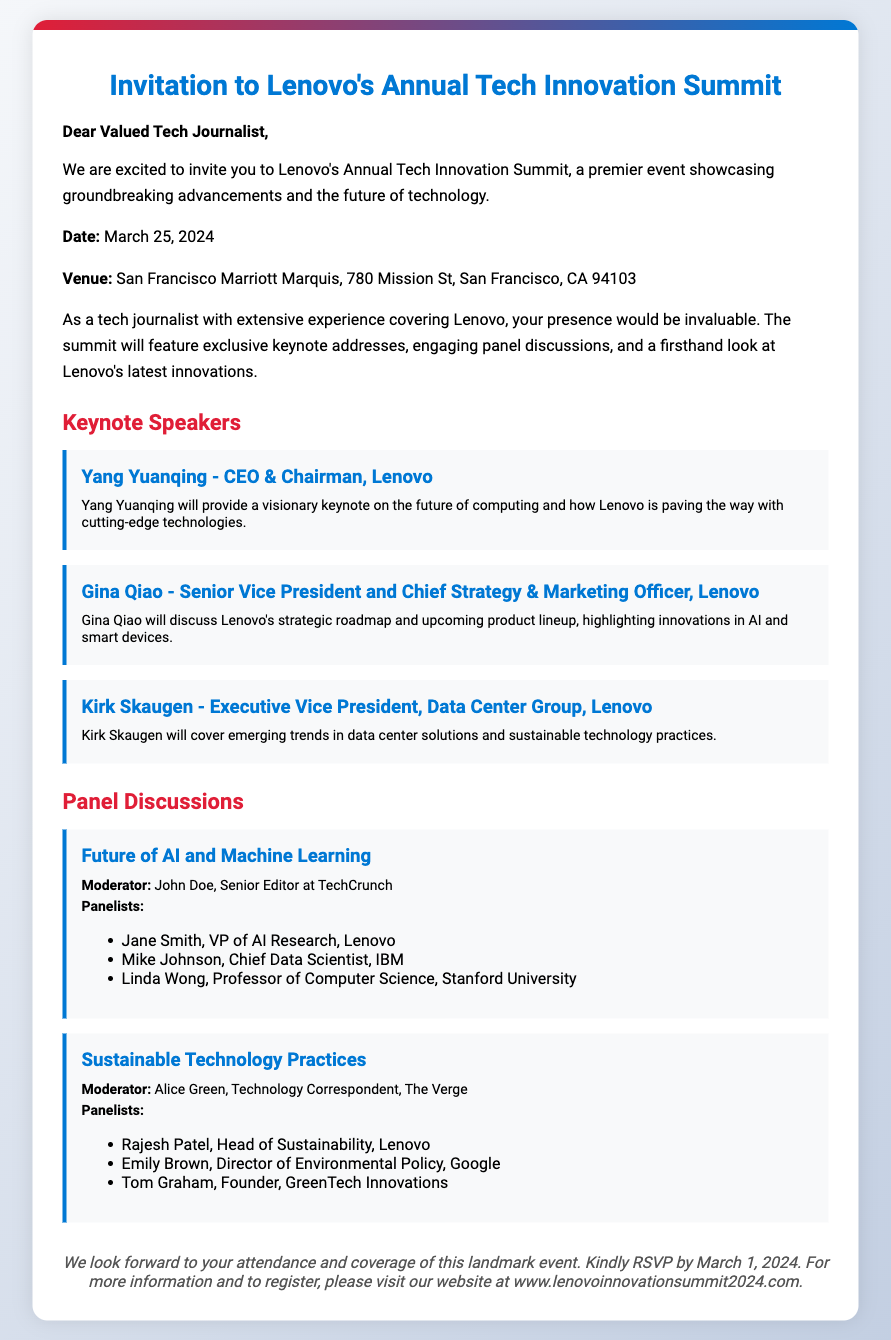What is the date of the event? The date for Lenovo's Annual Tech Innovation Summit is clearly stated in the document.
Answer: March 25, 2024 Where is the event taking place? The document specifies the venue where the summit will be held, providing the complete address.
Answer: San Francisco Marriott Marquis, 780 Mission St, San Francisco, CA 94103 Who is the keynote speaker that is the CEO of Lenovo? The document lists the keynote speakers along with their titles, making it easy to identify the CEO.
Answer: Yang Yuanqing What topic will Kirk Skaugen cover in his keynote? The specific topic of each keynote address is mentioned, allowing for easy extraction of this information.
Answer: Emerging trends in data center solutions and sustainable technology practices Who is moderating the panel on AI and Machine Learning? The document includes a list of moderators for each panel discussion, from which this information can be found.
Answer: John Doe How many keynote speakers are mentioned? The document lists the keynote speakers, and counting them provides the answer.
Answer: Three What is the RSVP deadline for the event? The document specifies a deadline for RSVPs, enabling this retrieval.
Answer: March 1, 2024 Which company is represented by Rajesh Patel on the sustainability panel? The document identifies panelists along with their associated companies, allowing for this answer to be extracted.
Answer: Lenovo What is the title of the panel moderated by Alice Green? The document provides titles for each panel discussion along with the moderators, making this information accessible.
Answer: Sustainable Technology Practices 